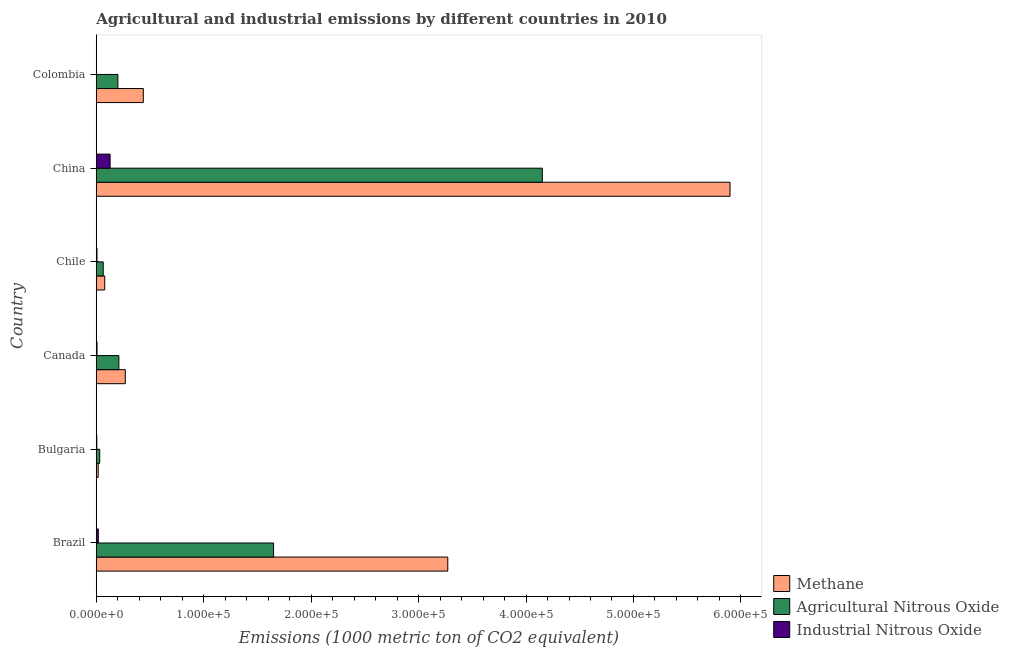Are the number of bars per tick equal to the number of legend labels?
Keep it short and to the point. Yes. Are the number of bars on each tick of the Y-axis equal?
Keep it short and to the point. Yes. What is the label of the 2nd group of bars from the top?
Your response must be concise. China. What is the amount of agricultural nitrous oxide emissions in Colombia?
Keep it short and to the point. 2.01e+04. Across all countries, what is the maximum amount of industrial nitrous oxide emissions?
Offer a very short reply. 1.29e+04. Across all countries, what is the minimum amount of methane emissions?
Keep it short and to the point. 1771.6. What is the total amount of industrial nitrous oxide emissions in the graph?
Make the answer very short. 1.67e+04. What is the difference between the amount of agricultural nitrous oxide emissions in Bulgaria and that in Canada?
Make the answer very short. -1.78e+04. What is the difference between the amount of methane emissions in Colombia and the amount of agricultural nitrous oxide emissions in Chile?
Ensure brevity in your answer.  3.73e+04. What is the average amount of industrial nitrous oxide emissions per country?
Provide a short and direct response. 2788.7. What is the difference between the amount of industrial nitrous oxide emissions and amount of methane emissions in Colombia?
Your answer should be compact. -4.37e+04. In how many countries, is the amount of industrial nitrous oxide emissions greater than 480000 metric ton?
Make the answer very short. 0. What is the ratio of the amount of agricultural nitrous oxide emissions in Brazil to that in Canada?
Offer a terse response. 7.84. Is the difference between the amount of agricultural nitrous oxide emissions in Bulgaria and Chile greater than the difference between the amount of methane emissions in Bulgaria and Chile?
Provide a short and direct response. Yes. What is the difference between the highest and the second highest amount of agricultural nitrous oxide emissions?
Your answer should be very brief. 2.50e+05. What is the difference between the highest and the lowest amount of methane emissions?
Your response must be concise. 5.88e+05. Is the sum of the amount of agricultural nitrous oxide emissions in Brazil and Colombia greater than the maximum amount of methane emissions across all countries?
Your answer should be compact. No. What does the 1st bar from the top in Bulgaria represents?
Your response must be concise. Industrial Nitrous Oxide. What does the 2nd bar from the bottom in Canada represents?
Offer a terse response. Agricultural Nitrous Oxide. How many bars are there?
Keep it short and to the point. 18. How many countries are there in the graph?
Your answer should be very brief. 6. What is the difference between two consecutive major ticks on the X-axis?
Provide a short and direct response. 1.00e+05. Are the values on the major ticks of X-axis written in scientific E-notation?
Your answer should be compact. Yes. Does the graph contain any zero values?
Your answer should be very brief. No. Does the graph contain grids?
Offer a terse response. No. How many legend labels are there?
Provide a short and direct response. 3. What is the title of the graph?
Give a very brief answer. Agricultural and industrial emissions by different countries in 2010. What is the label or title of the X-axis?
Make the answer very short. Emissions (1000 metric ton of CO2 equivalent). What is the Emissions (1000 metric ton of CO2 equivalent) of Methane in Brazil?
Provide a short and direct response. 3.27e+05. What is the Emissions (1000 metric ton of CO2 equivalent) of Agricultural Nitrous Oxide in Brazil?
Keep it short and to the point. 1.65e+05. What is the Emissions (1000 metric ton of CO2 equivalent) of Industrial Nitrous Oxide in Brazil?
Your answer should be very brief. 1890.3. What is the Emissions (1000 metric ton of CO2 equivalent) of Methane in Bulgaria?
Provide a short and direct response. 1771.6. What is the Emissions (1000 metric ton of CO2 equivalent) of Agricultural Nitrous Oxide in Bulgaria?
Your response must be concise. 3199.8. What is the Emissions (1000 metric ton of CO2 equivalent) of Industrial Nitrous Oxide in Bulgaria?
Provide a succinct answer. 492.6. What is the Emissions (1000 metric ton of CO2 equivalent) of Methane in Canada?
Your response must be concise. 2.70e+04. What is the Emissions (1000 metric ton of CO2 equivalent) of Agricultural Nitrous Oxide in Canada?
Make the answer very short. 2.10e+04. What is the Emissions (1000 metric ton of CO2 equivalent) of Industrial Nitrous Oxide in Canada?
Your answer should be very brief. 700.8. What is the Emissions (1000 metric ton of CO2 equivalent) of Methane in Chile?
Provide a short and direct response. 7883.7. What is the Emissions (1000 metric ton of CO2 equivalent) of Agricultural Nitrous Oxide in Chile?
Provide a succinct answer. 6472.2. What is the Emissions (1000 metric ton of CO2 equivalent) in Industrial Nitrous Oxide in Chile?
Provide a short and direct response. 676.3. What is the Emissions (1000 metric ton of CO2 equivalent) of Methane in China?
Provide a succinct answer. 5.90e+05. What is the Emissions (1000 metric ton of CO2 equivalent) in Agricultural Nitrous Oxide in China?
Ensure brevity in your answer.  4.15e+05. What is the Emissions (1000 metric ton of CO2 equivalent) of Industrial Nitrous Oxide in China?
Your response must be concise. 1.29e+04. What is the Emissions (1000 metric ton of CO2 equivalent) in Methane in Colombia?
Provide a short and direct response. 4.38e+04. What is the Emissions (1000 metric ton of CO2 equivalent) in Agricultural Nitrous Oxide in Colombia?
Ensure brevity in your answer.  2.01e+04. What is the Emissions (1000 metric ton of CO2 equivalent) of Industrial Nitrous Oxide in Colombia?
Ensure brevity in your answer.  85.2. Across all countries, what is the maximum Emissions (1000 metric ton of CO2 equivalent) of Methane?
Provide a succinct answer. 5.90e+05. Across all countries, what is the maximum Emissions (1000 metric ton of CO2 equivalent) in Agricultural Nitrous Oxide?
Ensure brevity in your answer.  4.15e+05. Across all countries, what is the maximum Emissions (1000 metric ton of CO2 equivalent) in Industrial Nitrous Oxide?
Keep it short and to the point. 1.29e+04. Across all countries, what is the minimum Emissions (1000 metric ton of CO2 equivalent) in Methane?
Offer a very short reply. 1771.6. Across all countries, what is the minimum Emissions (1000 metric ton of CO2 equivalent) of Agricultural Nitrous Oxide?
Your answer should be compact. 3199.8. Across all countries, what is the minimum Emissions (1000 metric ton of CO2 equivalent) of Industrial Nitrous Oxide?
Offer a very short reply. 85.2. What is the total Emissions (1000 metric ton of CO2 equivalent) of Methane in the graph?
Offer a very short reply. 9.97e+05. What is the total Emissions (1000 metric ton of CO2 equivalent) of Agricultural Nitrous Oxide in the graph?
Offer a very short reply. 6.31e+05. What is the total Emissions (1000 metric ton of CO2 equivalent) of Industrial Nitrous Oxide in the graph?
Provide a succinct answer. 1.67e+04. What is the difference between the Emissions (1000 metric ton of CO2 equivalent) in Methane in Brazil and that in Bulgaria?
Your answer should be compact. 3.25e+05. What is the difference between the Emissions (1000 metric ton of CO2 equivalent) in Agricultural Nitrous Oxide in Brazil and that in Bulgaria?
Provide a short and direct response. 1.62e+05. What is the difference between the Emissions (1000 metric ton of CO2 equivalent) of Industrial Nitrous Oxide in Brazil and that in Bulgaria?
Offer a terse response. 1397.7. What is the difference between the Emissions (1000 metric ton of CO2 equivalent) of Methane in Brazil and that in Canada?
Offer a terse response. 3.00e+05. What is the difference between the Emissions (1000 metric ton of CO2 equivalent) of Agricultural Nitrous Oxide in Brazil and that in Canada?
Give a very brief answer. 1.44e+05. What is the difference between the Emissions (1000 metric ton of CO2 equivalent) in Industrial Nitrous Oxide in Brazil and that in Canada?
Provide a succinct answer. 1189.5. What is the difference between the Emissions (1000 metric ton of CO2 equivalent) of Methane in Brazil and that in Chile?
Give a very brief answer. 3.19e+05. What is the difference between the Emissions (1000 metric ton of CO2 equivalent) in Agricultural Nitrous Oxide in Brazil and that in Chile?
Provide a succinct answer. 1.59e+05. What is the difference between the Emissions (1000 metric ton of CO2 equivalent) of Industrial Nitrous Oxide in Brazil and that in Chile?
Ensure brevity in your answer.  1214. What is the difference between the Emissions (1000 metric ton of CO2 equivalent) in Methane in Brazil and that in China?
Offer a terse response. -2.63e+05. What is the difference between the Emissions (1000 metric ton of CO2 equivalent) in Agricultural Nitrous Oxide in Brazil and that in China?
Keep it short and to the point. -2.50e+05. What is the difference between the Emissions (1000 metric ton of CO2 equivalent) in Industrial Nitrous Oxide in Brazil and that in China?
Provide a succinct answer. -1.10e+04. What is the difference between the Emissions (1000 metric ton of CO2 equivalent) in Methane in Brazil and that in Colombia?
Give a very brief answer. 2.83e+05. What is the difference between the Emissions (1000 metric ton of CO2 equivalent) in Agricultural Nitrous Oxide in Brazil and that in Colombia?
Your response must be concise. 1.45e+05. What is the difference between the Emissions (1000 metric ton of CO2 equivalent) of Industrial Nitrous Oxide in Brazil and that in Colombia?
Make the answer very short. 1805.1. What is the difference between the Emissions (1000 metric ton of CO2 equivalent) of Methane in Bulgaria and that in Canada?
Your response must be concise. -2.52e+04. What is the difference between the Emissions (1000 metric ton of CO2 equivalent) in Agricultural Nitrous Oxide in Bulgaria and that in Canada?
Provide a short and direct response. -1.78e+04. What is the difference between the Emissions (1000 metric ton of CO2 equivalent) in Industrial Nitrous Oxide in Bulgaria and that in Canada?
Offer a very short reply. -208.2. What is the difference between the Emissions (1000 metric ton of CO2 equivalent) in Methane in Bulgaria and that in Chile?
Keep it short and to the point. -6112.1. What is the difference between the Emissions (1000 metric ton of CO2 equivalent) in Agricultural Nitrous Oxide in Bulgaria and that in Chile?
Your response must be concise. -3272.4. What is the difference between the Emissions (1000 metric ton of CO2 equivalent) of Industrial Nitrous Oxide in Bulgaria and that in Chile?
Provide a short and direct response. -183.7. What is the difference between the Emissions (1000 metric ton of CO2 equivalent) in Methane in Bulgaria and that in China?
Your response must be concise. -5.88e+05. What is the difference between the Emissions (1000 metric ton of CO2 equivalent) of Agricultural Nitrous Oxide in Bulgaria and that in China?
Your answer should be compact. -4.12e+05. What is the difference between the Emissions (1000 metric ton of CO2 equivalent) in Industrial Nitrous Oxide in Bulgaria and that in China?
Provide a short and direct response. -1.24e+04. What is the difference between the Emissions (1000 metric ton of CO2 equivalent) of Methane in Bulgaria and that in Colombia?
Provide a succinct answer. -4.20e+04. What is the difference between the Emissions (1000 metric ton of CO2 equivalent) in Agricultural Nitrous Oxide in Bulgaria and that in Colombia?
Make the answer very short. -1.69e+04. What is the difference between the Emissions (1000 metric ton of CO2 equivalent) of Industrial Nitrous Oxide in Bulgaria and that in Colombia?
Your response must be concise. 407.4. What is the difference between the Emissions (1000 metric ton of CO2 equivalent) in Methane in Canada and that in Chile?
Your answer should be compact. 1.91e+04. What is the difference between the Emissions (1000 metric ton of CO2 equivalent) in Agricultural Nitrous Oxide in Canada and that in Chile?
Make the answer very short. 1.46e+04. What is the difference between the Emissions (1000 metric ton of CO2 equivalent) in Industrial Nitrous Oxide in Canada and that in Chile?
Make the answer very short. 24.5. What is the difference between the Emissions (1000 metric ton of CO2 equivalent) in Methane in Canada and that in China?
Make the answer very short. -5.63e+05. What is the difference between the Emissions (1000 metric ton of CO2 equivalent) of Agricultural Nitrous Oxide in Canada and that in China?
Provide a short and direct response. -3.94e+05. What is the difference between the Emissions (1000 metric ton of CO2 equivalent) in Industrial Nitrous Oxide in Canada and that in China?
Provide a succinct answer. -1.22e+04. What is the difference between the Emissions (1000 metric ton of CO2 equivalent) of Methane in Canada and that in Colombia?
Ensure brevity in your answer.  -1.68e+04. What is the difference between the Emissions (1000 metric ton of CO2 equivalent) in Agricultural Nitrous Oxide in Canada and that in Colombia?
Your response must be concise. 928.6. What is the difference between the Emissions (1000 metric ton of CO2 equivalent) in Industrial Nitrous Oxide in Canada and that in Colombia?
Provide a succinct answer. 615.6. What is the difference between the Emissions (1000 metric ton of CO2 equivalent) of Methane in Chile and that in China?
Provide a succinct answer. -5.82e+05. What is the difference between the Emissions (1000 metric ton of CO2 equivalent) in Agricultural Nitrous Oxide in Chile and that in China?
Ensure brevity in your answer.  -4.09e+05. What is the difference between the Emissions (1000 metric ton of CO2 equivalent) in Industrial Nitrous Oxide in Chile and that in China?
Make the answer very short. -1.22e+04. What is the difference between the Emissions (1000 metric ton of CO2 equivalent) in Methane in Chile and that in Colombia?
Your response must be concise. -3.59e+04. What is the difference between the Emissions (1000 metric ton of CO2 equivalent) of Agricultural Nitrous Oxide in Chile and that in Colombia?
Keep it short and to the point. -1.36e+04. What is the difference between the Emissions (1000 metric ton of CO2 equivalent) of Industrial Nitrous Oxide in Chile and that in Colombia?
Your response must be concise. 591.1. What is the difference between the Emissions (1000 metric ton of CO2 equivalent) of Methane in China and that in Colombia?
Provide a short and direct response. 5.46e+05. What is the difference between the Emissions (1000 metric ton of CO2 equivalent) in Agricultural Nitrous Oxide in China and that in Colombia?
Your response must be concise. 3.95e+05. What is the difference between the Emissions (1000 metric ton of CO2 equivalent) of Industrial Nitrous Oxide in China and that in Colombia?
Offer a terse response. 1.28e+04. What is the difference between the Emissions (1000 metric ton of CO2 equivalent) in Methane in Brazil and the Emissions (1000 metric ton of CO2 equivalent) in Agricultural Nitrous Oxide in Bulgaria?
Your answer should be compact. 3.24e+05. What is the difference between the Emissions (1000 metric ton of CO2 equivalent) of Methane in Brazil and the Emissions (1000 metric ton of CO2 equivalent) of Industrial Nitrous Oxide in Bulgaria?
Keep it short and to the point. 3.27e+05. What is the difference between the Emissions (1000 metric ton of CO2 equivalent) of Agricultural Nitrous Oxide in Brazil and the Emissions (1000 metric ton of CO2 equivalent) of Industrial Nitrous Oxide in Bulgaria?
Ensure brevity in your answer.  1.65e+05. What is the difference between the Emissions (1000 metric ton of CO2 equivalent) in Methane in Brazil and the Emissions (1000 metric ton of CO2 equivalent) in Agricultural Nitrous Oxide in Canada?
Your answer should be very brief. 3.06e+05. What is the difference between the Emissions (1000 metric ton of CO2 equivalent) of Methane in Brazil and the Emissions (1000 metric ton of CO2 equivalent) of Industrial Nitrous Oxide in Canada?
Give a very brief answer. 3.26e+05. What is the difference between the Emissions (1000 metric ton of CO2 equivalent) of Agricultural Nitrous Oxide in Brazil and the Emissions (1000 metric ton of CO2 equivalent) of Industrial Nitrous Oxide in Canada?
Your response must be concise. 1.64e+05. What is the difference between the Emissions (1000 metric ton of CO2 equivalent) of Methane in Brazil and the Emissions (1000 metric ton of CO2 equivalent) of Agricultural Nitrous Oxide in Chile?
Give a very brief answer. 3.21e+05. What is the difference between the Emissions (1000 metric ton of CO2 equivalent) of Methane in Brazil and the Emissions (1000 metric ton of CO2 equivalent) of Industrial Nitrous Oxide in Chile?
Keep it short and to the point. 3.26e+05. What is the difference between the Emissions (1000 metric ton of CO2 equivalent) in Agricultural Nitrous Oxide in Brazil and the Emissions (1000 metric ton of CO2 equivalent) in Industrial Nitrous Oxide in Chile?
Provide a short and direct response. 1.64e+05. What is the difference between the Emissions (1000 metric ton of CO2 equivalent) of Methane in Brazil and the Emissions (1000 metric ton of CO2 equivalent) of Agricultural Nitrous Oxide in China?
Keep it short and to the point. -8.80e+04. What is the difference between the Emissions (1000 metric ton of CO2 equivalent) in Methane in Brazil and the Emissions (1000 metric ton of CO2 equivalent) in Industrial Nitrous Oxide in China?
Provide a succinct answer. 3.14e+05. What is the difference between the Emissions (1000 metric ton of CO2 equivalent) in Agricultural Nitrous Oxide in Brazil and the Emissions (1000 metric ton of CO2 equivalent) in Industrial Nitrous Oxide in China?
Your answer should be very brief. 1.52e+05. What is the difference between the Emissions (1000 metric ton of CO2 equivalent) in Methane in Brazil and the Emissions (1000 metric ton of CO2 equivalent) in Agricultural Nitrous Oxide in Colombia?
Ensure brevity in your answer.  3.07e+05. What is the difference between the Emissions (1000 metric ton of CO2 equivalent) of Methane in Brazil and the Emissions (1000 metric ton of CO2 equivalent) of Industrial Nitrous Oxide in Colombia?
Your answer should be very brief. 3.27e+05. What is the difference between the Emissions (1000 metric ton of CO2 equivalent) in Agricultural Nitrous Oxide in Brazil and the Emissions (1000 metric ton of CO2 equivalent) in Industrial Nitrous Oxide in Colombia?
Your response must be concise. 1.65e+05. What is the difference between the Emissions (1000 metric ton of CO2 equivalent) of Methane in Bulgaria and the Emissions (1000 metric ton of CO2 equivalent) of Agricultural Nitrous Oxide in Canada?
Provide a succinct answer. -1.93e+04. What is the difference between the Emissions (1000 metric ton of CO2 equivalent) in Methane in Bulgaria and the Emissions (1000 metric ton of CO2 equivalent) in Industrial Nitrous Oxide in Canada?
Offer a very short reply. 1070.8. What is the difference between the Emissions (1000 metric ton of CO2 equivalent) in Agricultural Nitrous Oxide in Bulgaria and the Emissions (1000 metric ton of CO2 equivalent) in Industrial Nitrous Oxide in Canada?
Offer a terse response. 2499. What is the difference between the Emissions (1000 metric ton of CO2 equivalent) of Methane in Bulgaria and the Emissions (1000 metric ton of CO2 equivalent) of Agricultural Nitrous Oxide in Chile?
Your response must be concise. -4700.6. What is the difference between the Emissions (1000 metric ton of CO2 equivalent) in Methane in Bulgaria and the Emissions (1000 metric ton of CO2 equivalent) in Industrial Nitrous Oxide in Chile?
Ensure brevity in your answer.  1095.3. What is the difference between the Emissions (1000 metric ton of CO2 equivalent) in Agricultural Nitrous Oxide in Bulgaria and the Emissions (1000 metric ton of CO2 equivalent) in Industrial Nitrous Oxide in Chile?
Your answer should be very brief. 2523.5. What is the difference between the Emissions (1000 metric ton of CO2 equivalent) of Methane in Bulgaria and the Emissions (1000 metric ton of CO2 equivalent) of Agricultural Nitrous Oxide in China?
Give a very brief answer. -4.13e+05. What is the difference between the Emissions (1000 metric ton of CO2 equivalent) of Methane in Bulgaria and the Emissions (1000 metric ton of CO2 equivalent) of Industrial Nitrous Oxide in China?
Offer a terse response. -1.11e+04. What is the difference between the Emissions (1000 metric ton of CO2 equivalent) of Agricultural Nitrous Oxide in Bulgaria and the Emissions (1000 metric ton of CO2 equivalent) of Industrial Nitrous Oxide in China?
Your answer should be very brief. -9687.2. What is the difference between the Emissions (1000 metric ton of CO2 equivalent) in Methane in Bulgaria and the Emissions (1000 metric ton of CO2 equivalent) in Agricultural Nitrous Oxide in Colombia?
Offer a very short reply. -1.83e+04. What is the difference between the Emissions (1000 metric ton of CO2 equivalent) in Methane in Bulgaria and the Emissions (1000 metric ton of CO2 equivalent) in Industrial Nitrous Oxide in Colombia?
Ensure brevity in your answer.  1686.4. What is the difference between the Emissions (1000 metric ton of CO2 equivalent) in Agricultural Nitrous Oxide in Bulgaria and the Emissions (1000 metric ton of CO2 equivalent) in Industrial Nitrous Oxide in Colombia?
Give a very brief answer. 3114.6. What is the difference between the Emissions (1000 metric ton of CO2 equivalent) in Methane in Canada and the Emissions (1000 metric ton of CO2 equivalent) in Agricultural Nitrous Oxide in Chile?
Offer a very short reply. 2.05e+04. What is the difference between the Emissions (1000 metric ton of CO2 equivalent) of Methane in Canada and the Emissions (1000 metric ton of CO2 equivalent) of Industrial Nitrous Oxide in Chile?
Provide a short and direct response. 2.63e+04. What is the difference between the Emissions (1000 metric ton of CO2 equivalent) of Agricultural Nitrous Oxide in Canada and the Emissions (1000 metric ton of CO2 equivalent) of Industrial Nitrous Oxide in Chile?
Offer a very short reply. 2.04e+04. What is the difference between the Emissions (1000 metric ton of CO2 equivalent) of Methane in Canada and the Emissions (1000 metric ton of CO2 equivalent) of Agricultural Nitrous Oxide in China?
Ensure brevity in your answer.  -3.88e+05. What is the difference between the Emissions (1000 metric ton of CO2 equivalent) of Methane in Canada and the Emissions (1000 metric ton of CO2 equivalent) of Industrial Nitrous Oxide in China?
Provide a short and direct response. 1.41e+04. What is the difference between the Emissions (1000 metric ton of CO2 equivalent) in Agricultural Nitrous Oxide in Canada and the Emissions (1000 metric ton of CO2 equivalent) in Industrial Nitrous Oxide in China?
Provide a succinct answer. 8158.1. What is the difference between the Emissions (1000 metric ton of CO2 equivalent) of Methane in Canada and the Emissions (1000 metric ton of CO2 equivalent) of Agricultural Nitrous Oxide in Colombia?
Your answer should be very brief. 6902.8. What is the difference between the Emissions (1000 metric ton of CO2 equivalent) of Methane in Canada and the Emissions (1000 metric ton of CO2 equivalent) of Industrial Nitrous Oxide in Colombia?
Make the answer very short. 2.69e+04. What is the difference between the Emissions (1000 metric ton of CO2 equivalent) of Agricultural Nitrous Oxide in Canada and the Emissions (1000 metric ton of CO2 equivalent) of Industrial Nitrous Oxide in Colombia?
Ensure brevity in your answer.  2.10e+04. What is the difference between the Emissions (1000 metric ton of CO2 equivalent) of Methane in Chile and the Emissions (1000 metric ton of CO2 equivalent) of Agricultural Nitrous Oxide in China?
Your answer should be very brief. -4.07e+05. What is the difference between the Emissions (1000 metric ton of CO2 equivalent) in Methane in Chile and the Emissions (1000 metric ton of CO2 equivalent) in Industrial Nitrous Oxide in China?
Provide a succinct answer. -5003.3. What is the difference between the Emissions (1000 metric ton of CO2 equivalent) of Agricultural Nitrous Oxide in Chile and the Emissions (1000 metric ton of CO2 equivalent) of Industrial Nitrous Oxide in China?
Your response must be concise. -6414.8. What is the difference between the Emissions (1000 metric ton of CO2 equivalent) of Methane in Chile and the Emissions (1000 metric ton of CO2 equivalent) of Agricultural Nitrous Oxide in Colombia?
Your response must be concise. -1.22e+04. What is the difference between the Emissions (1000 metric ton of CO2 equivalent) of Methane in Chile and the Emissions (1000 metric ton of CO2 equivalent) of Industrial Nitrous Oxide in Colombia?
Offer a terse response. 7798.5. What is the difference between the Emissions (1000 metric ton of CO2 equivalent) of Agricultural Nitrous Oxide in Chile and the Emissions (1000 metric ton of CO2 equivalent) of Industrial Nitrous Oxide in Colombia?
Offer a very short reply. 6387. What is the difference between the Emissions (1000 metric ton of CO2 equivalent) of Methane in China and the Emissions (1000 metric ton of CO2 equivalent) of Agricultural Nitrous Oxide in Colombia?
Provide a short and direct response. 5.70e+05. What is the difference between the Emissions (1000 metric ton of CO2 equivalent) in Methane in China and the Emissions (1000 metric ton of CO2 equivalent) in Industrial Nitrous Oxide in Colombia?
Offer a terse response. 5.90e+05. What is the difference between the Emissions (1000 metric ton of CO2 equivalent) of Agricultural Nitrous Oxide in China and the Emissions (1000 metric ton of CO2 equivalent) of Industrial Nitrous Oxide in Colombia?
Offer a very short reply. 4.15e+05. What is the average Emissions (1000 metric ton of CO2 equivalent) of Methane per country?
Keep it short and to the point. 1.66e+05. What is the average Emissions (1000 metric ton of CO2 equivalent) of Agricultural Nitrous Oxide per country?
Your answer should be very brief. 1.05e+05. What is the average Emissions (1000 metric ton of CO2 equivalent) in Industrial Nitrous Oxide per country?
Your answer should be compact. 2788.7. What is the difference between the Emissions (1000 metric ton of CO2 equivalent) of Methane and Emissions (1000 metric ton of CO2 equivalent) of Agricultural Nitrous Oxide in Brazil?
Offer a very short reply. 1.62e+05. What is the difference between the Emissions (1000 metric ton of CO2 equivalent) of Methane and Emissions (1000 metric ton of CO2 equivalent) of Industrial Nitrous Oxide in Brazil?
Offer a very short reply. 3.25e+05. What is the difference between the Emissions (1000 metric ton of CO2 equivalent) of Agricultural Nitrous Oxide and Emissions (1000 metric ton of CO2 equivalent) of Industrial Nitrous Oxide in Brazil?
Your answer should be compact. 1.63e+05. What is the difference between the Emissions (1000 metric ton of CO2 equivalent) in Methane and Emissions (1000 metric ton of CO2 equivalent) in Agricultural Nitrous Oxide in Bulgaria?
Your answer should be very brief. -1428.2. What is the difference between the Emissions (1000 metric ton of CO2 equivalent) of Methane and Emissions (1000 metric ton of CO2 equivalent) of Industrial Nitrous Oxide in Bulgaria?
Your answer should be very brief. 1279. What is the difference between the Emissions (1000 metric ton of CO2 equivalent) in Agricultural Nitrous Oxide and Emissions (1000 metric ton of CO2 equivalent) in Industrial Nitrous Oxide in Bulgaria?
Make the answer very short. 2707.2. What is the difference between the Emissions (1000 metric ton of CO2 equivalent) in Methane and Emissions (1000 metric ton of CO2 equivalent) in Agricultural Nitrous Oxide in Canada?
Offer a terse response. 5974.2. What is the difference between the Emissions (1000 metric ton of CO2 equivalent) of Methane and Emissions (1000 metric ton of CO2 equivalent) of Industrial Nitrous Oxide in Canada?
Offer a very short reply. 2.63e+04. What is the difference between the Emissions (1000 metric ton of CO2 equivalent) of Agricultural Nitrous Oxide and Emissions (1000 metric ton of CO2 equivalent) of Industrial Nitrous Oxide in Canada?
Keep it short and to the point. 2.03e+04. What is the difference between the Emissions (1000 metric ton of CO2 equivalent) in Methane and Emissions (1000 metric ton of CO2 equivalent) in Agricultural Nitrous Oxide in Chile?
Offer a terse response. 1411.5. What is the difference between the Emissions (1000 metric ton of CO2 equivalent) of Methane and Emissions (1000 metric ton of CO2 equivalent) of Industrial Nitrous Oxide in Chile?
Your answer should be very brief. 7207.4. What is the difference between the Emissions (1000 metric ton of CO2 equivalent) of Agricultural Nitrous Oxide and Emissions (1000 metric ton of CO2 equivalent) of Industrial Nitrous Oxide in Chile?
Your answer should be very brief. 5795.9. What is the difference between the Emissions (1000 metric ton of CO2 equivalent) of Methane and Emissions (1000 metric ton of CO2 equivalent) of Agricultural Nitrous Oxide in China?
Your response must be concise. 1.75e+05. What is the difference between the Emissions (1000 metric ton of CO2 equivalent) of Methane and Emissions (1000 metric ton of CO2 equivalent) of Industrial Nitrous Oxide in China?
Give a very brief answer. 5.77e+05. What is the difference between the Emissions (1000 metric ton of CO2 equivalent) in Agricultural Nitrous Oxide and Emissions (1000 metric ton of CO2 equivalent) in Industrial Nitrous Oxide in China?
Your response must be concise. 4.02e+05. What is the difference between the Emissions (1000 metric ton of CO2 equivalent) of Methane and Emissions (1000 metric ton of CO2 equivalent) of Agricultural Nitrous Oxide in Colombia?
Offer a very short reply. 2.37e+04. What is the difference between the Emissions (1000 metric ton of CO2 equivalent) of Methane and Emissions (1000 metric ton of CO2 equivalent) of Industrial Nitrous Oxide in Colombia?
Provide a succinct answer. 4.37e+04. What is the difference between the Emissions (1000 metric ton of CO2 equivalent) in Agricultural Nitrous Oxide and Emissions (1000 metric ton of CO2 equivalent) in Industrial Nitrous Oxide in Colombia?
Make the answer very short. 2.00e+04. What is the ratio of the Emissions (1000 metric ton of CO2 equivalent) in Methane in Brazil to that in Bulgaria?
Make the answer very short. 184.67. What is the ratio of the Emissions (1000 metric ton of CO2 equivalent) of Agricultural Nitrous Oxide in Brazil to that in Bulgaria?
Make the answer very short. 51.58. What is the ratio of the Emissions (1000 metric ton of CO2 equivalent) in Industrial Nitrous Oxide in Brazil to that in Bulgaria?
Ensure brevity in your answer.  3.84. What is the ratio of the Emissions (1000 metric ton of CO2 equivalent) in Methane in Brazil to that in Canada?
Make the answer very short. 12.11. What is the ratio of the Emissions (1000 metric ton of CO2 equivalent) in Agricultural Nitrous Oxide in Brazil to that in Canada?
Your response must be concise. 7.84. What is the ratio of the Emissions (1000 metric ton of CO2 equivalent) of Industrial Nitrous Oxide in Brazil to that in Canada?
Your response must be concise. 2.7. What is the ratio of the Emissions (1000 metric ton of CO2 equivalent) in Methane in Brazil to that in Chile?
Make the answer very short. 41.5. What is the ratio of the Emissions (1000 metric ton of CO2 equivalent) of Agricultural Nitrous Oxide in Brazil to that in Chile?
Provide a succinct answer. 25.5. What is the ratio of the Emissions (1000 metric ton of CO2 equivalent) of Industrial Nitrous Oxide in Brazil to that in Chile?
Keep it short and to the point. 2.8. What is the ratio of the Emissions (1000 metric ton of CO2 equivalent) in Methane in Brazil to that in China?
Ensure brevity in your answer.  0.55. What is the ratio of the Emissions (1000 metric ton of CO2 equivalent) of Agricultural Nitrous Oxide in Brazil to that in China?
Provide a short and direct response. 0.4. What is the ratio of the Emissions (1000 metric ton of CO2 equivalent) of Industrial Nitrous Oxide in Brazil to that in China?
Offer a terse response. 0.15. What is the ratio of the Emissions (1000 metric ton of CO2 equivalent) in Methane in Brazil to that in Colombia?
Ensure brevity in your answer.  7.47. What is the ratio of the Emissions (1000 metric ton of CO2 equivalent) of Agricultural Nitrous Oxide in Brazil to that in Colombia?
Give a very brief answer. 8.2. What is the ratio of the Emissions (1000 metric ton of CO2 equivalent) of Industrial Nitrous Oxide in Brazil to that in Colombia?
Your response must be concise. 22.19. What is the ratio of the Emissions (1000 metric ton of CO2 equivalent) of Methane in Bulgaria to that in Canada?
Give a very brief answer. 0.07. What is the ratio of the Emissions (1000 metric ton of CO2 equivalent) in Agricultural Nitrous Oxide in Bulgaria to that in Canada?
Your answer should be very brief. 0.15. What is the ratio of the Emissions (1000 metric ton of CO2 equivalent) of Industrial Nitrous Oxide in Bulgaria to that in Canada?
Offer a very short reply. 0.7. What is the ratio of the Emissions (1000 metric ton of CO2 equivalent) of Methane in Bulgaria to that in Chile?
Offer a terse response. 0.22. What is the ratio of the Emissions (1000 metric ton of CO2 equivalent) of Agricultural Nitrous Oxide in Bulgaria to that in Chile?
Make the answer very short. 0.49. What is the ratio of the Emissions (1000 metric ton of CO2 equivalent) in Industrial Nitrous Oxide in Bulgaria to that in Chile?
Offer a very short reply. 0.73. What is the ratio of the Emissions (1000 metric ton of CO2 equivalent) in Methane in Bulgaria to that in China?
Offer a very short reply. 0. What is the ratio of the Emissions (1000 metric ton of CO2 equivalent) in Agricultural Nitrous Oxide in Bulgaria to that in China?
Provide a short and direct response. 0.01. What is the ratio of the Emissions (1000 metric ton of CO2 equivalent) of Industrial Nitrous Oxide in Bulgaria to that in China?
Your answer should be compact. 0.04. What is the ratio of the Emissions (1000 metric ton of CO2 equivalent) of Methane in Bulgaria to that in Colombia?
Give a very brief answer. 0.04. What is the ratio of the Emissions (1000 metric ton of CO2 equivalent) of Agricultural Nitrous Oxide in Bulgaria to that in Colombia?
Ensure brevity in your answer.  0.16. What is the ratio of the Emissions (1000 metric ton of CO2 equivalent) of Industrial Nitrous Oxide in Bulgaria to that in Colombia?
Offer a very short reply. 5.78. What is the ratio of the Emissions (1000 metric ton of CO2 equivalent) of Methane in Canada to that in Chile?
Offer a terse response. 3.43. What is the ratio of the Emissions (1000 metric ton of CO2 equivalent) in Agricultural Nitrous Oxide in Canada to that in Chile?
Provide a short and direct response. 3.25. What is the ratio of the Emissions (1000 metric ton of CO2 equivalent) of Industrial Nitrous Oxide in Canada to that in Chile?
Keep it short and to the point. 1.04. What is the ratio of the Emissions (1000 metric ton of CO2 equivalent) in Methane in Canada to that in China?
Offer a very short reply. 0.05. What is the ratio of the Emissions (1000 metric ton of CO2 equivalent) in Agricultural Nitrous Oxide in Canada to that in China?
Make the answer very short. 0.05. What is the ratio of the Emissions (1000 metric ton of CO2 equivalent) in Industrial Nitrous Oxide in Canada to that in China?
Ensure brevity in your answer.  0.05. What is the ratio of the Emissions (1000 metric ton of CO2 equivalent) in Methane in Canada to that in Colombia?
Provide a succinct answer. 0.62. What is the ratio of the Emissions (1000 metric ton of CO2 equivalent) in Agricultural Nitrous Oxide in Canada to that in Colombia?
Your answer should be very brief. 1.05. What is the ratio of the Emissions (1000 metric ton of CO2 equivalent) of Industrial Nitrous Oxide in Canada to that in Colombia?
Your answer should be very brief. 8.23. What is the ratio of the Emissions (1000 metric ton of CO2 equivalent) in Methane in Chile to that in China?
Offer a very short reply. 0.01. What is the ratio of the Emissions (1000 metric ton of CO2 equivalent) of Agricultural Nitrous Oxide in Chile to that in China?
Your answer should be compact. 0.02. What is the ratio of the Emissions (1000 metric ton of CO2 equivalent) of Industrial Nitrous Oxide in Chile to that in China?
Ensure brevity in your answer.  0.05. What is the ratio of the Emissions (1000 metric ton of CO2 equivalent) of Methane in Chile to that in Colombia?
Your answer should be very brief. 0.18. What is the ratio of the Emissions (1000 metric ton of CO2 equivalent) in Agricultural Nitrous Oxide in Chile to that in Colombia?
Your answer should be very brief. 0.32. What is the ratio of the Emissions (1000 metric ton of CO2 equivalent) in Industrial Nitrous Oxide in Chile to that in Colombia?
Provide a succinct answer. 7.94. What is the ratio of the Emissions (1000 metric ton of CO2 equivalent) of Methane in China to that in Colombia?
Give a very brief answer. 13.47. What is the ratio of the Emissions (1000 metric ton of CO2 equivalent) of Agricultural Nitrous Oxide in China to that in Colombia?
Ensure brevity in your answer.  20.64. What is the ratio of the Emissions (1000 metric ton of CO2 equivalent) of Industrial Nitrous Oxide in China to that in Colombia?
Keep it short and to the point. 151.26. What is the difference between the highest and the second highest Emissions (1000 metric ton of CO2 equivalent) in Methane?
Your response must be concise. 2.63e+05. What is the difference between the highest and the second highest Emissions (1000 metric ton of CO2 equivalent) in Agricultural Nitrous Oxide?
Make the answer very short. 2.50e+05. What is the difference between the highest and the second highest Emissions (1000 metric ton of CO2 equivalent) in Industrial Nitrous Oxide?
Keep it short and to the point. 1.10e+04. What is the difference between the highest and the lowest Emissions (1000 metric ton of CO2 equivalent) of Methane?
Offer a very short reply. 5.88e+05. What is the difference between the highest and the lowest Emissions (1000 metric ton of CO2 equivalent) of Agricultural Nitrous Oxide?
Your answer should be very brief. 4.12e+05. What is the difference between the highest and the lowest Emissions (1000 metric ton of CO2 equivalent) in Industrial Nitrous Oxide?
Your response must be concise. 1.28e+04. 